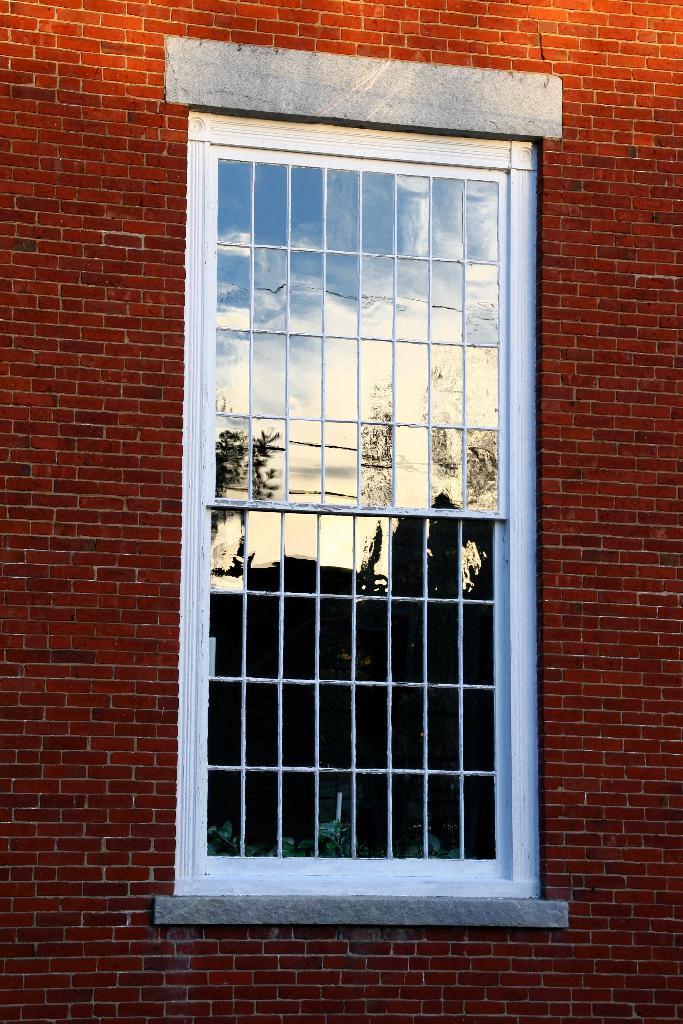Can you describe this image briefly? In the picture there is a brick wall and there is a window in between the wall. 